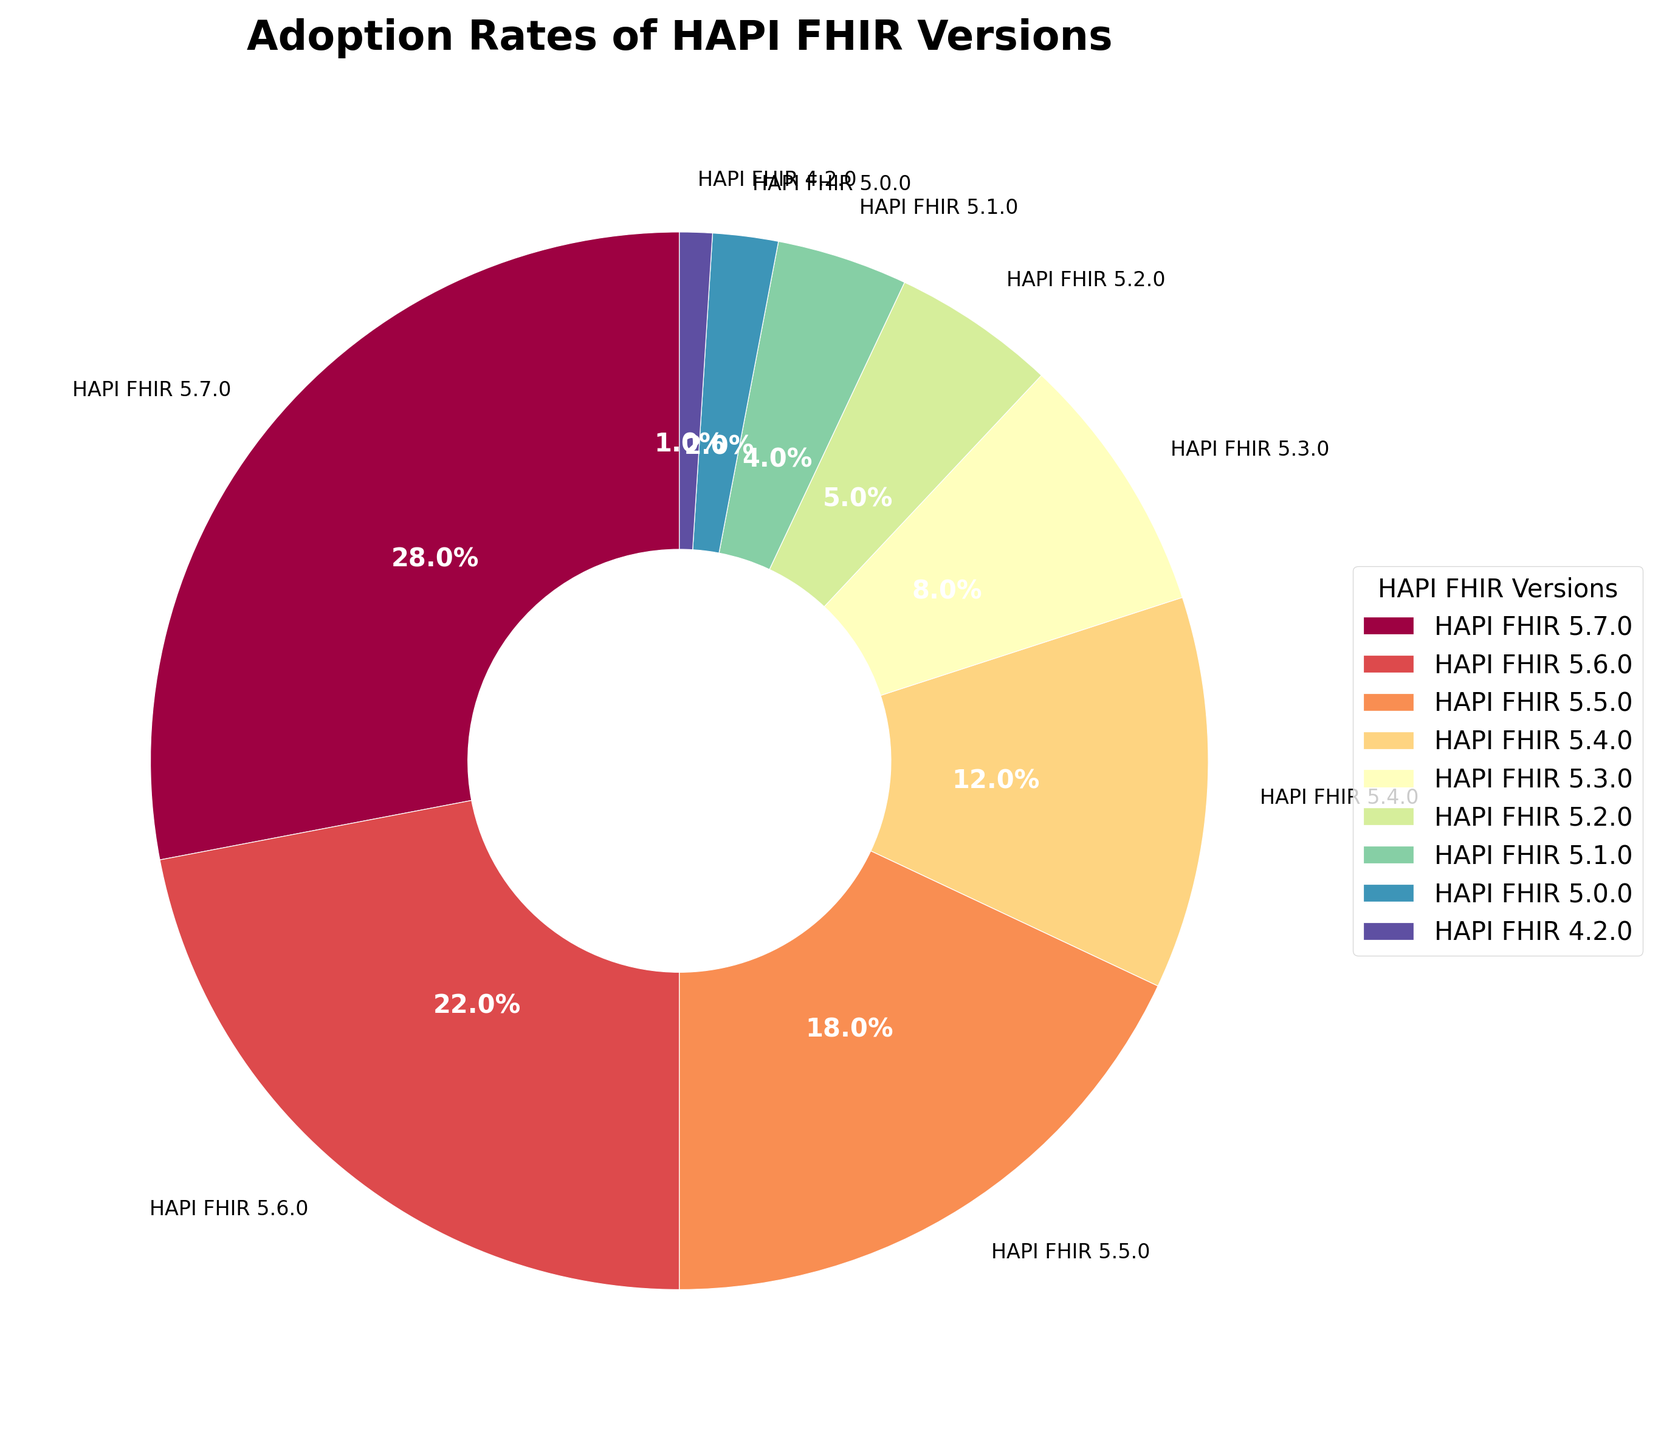What is the adoption percentage of HAPI FHIR 5.6.0? The pie chart shows each version and its corresponding adoption percentage. Locate the label for HAPI FHIR 5.6.0 and read the associated percentage value.
Answer: 22% Which HAPI FHIR version has the highest adoption rate? Identify the segment of the pie chart that is the largest and check the label associated with it. The largest segment represents the version with the highest adoption rate.
Answer: HAPI FHIR 5.7.0 What is the total adoption percentage of the versions HAPI FHIR 5.5.0 and HAPI FHIR 5.4.0 combined? Find the adoption percentages for HAPI FHIR 5.5.0 and HAPI FHIR 5.4.0 from the chart. Add these percentages together to get the total.
Answer: 30% Which version has a lower adoption percentage, HAPI FHIR 5.3.0 or HAPI FHIR 4.2.0? Compare the respective segments for HAPI FHIR 5.3.0 and HAPI FHIR 4.2.0. Check their adoption percentages directly from the pie chart.
Answer: HAPI FHIR 4.2.0 What are the adoption percentages for all versions represented by segments with a darker shade in the chart? Look at the color gradient in the pie chart and identify which segments have darker shades. Sum the adoption percentages for these versions. This assumes we are using natural shading where darker usually represents higher or significant values. Ensure specific segments are clearly distinguishable from the visual attributes described.
Answer: 63% (combining HAPI FHIR 5.7.0, HAPI FHIR 5.6.0, and HAPI FHIR 5.5.0) Which version sees a higher adoption rate: HAPI FHIR 5.1.0 or HAPI FHIR 5.0.0? Compare the adoption percentages directly on the pie chart for HAPI FHIR 5.1.0 and HAPI FHIR 5.0.0.
Answer: HAPI FHIR 5.1.0 What is the percentage difference between HAPI FHIR 5.7.0 and HAPI FHIR 5.5.0? Find the adoption percentages for both versions HAPI FHIR 5.7.0 and HAPI FHIR 5.5.0. Subtract the percentage of HAPI FHIR 5.5.0 from HAPI FHIR 5.7.0 to get the difference.
Answer: 10% What is the sum of the adoption rates for all versions that have an adoption percentage less than 10%? Identify all versions with adoption percentages less than 10%. Sum these percentages together to find the total.
Answer: 20% How many versions have an adoption rate greater than 15%? Count the number of segments in the pie chart that have adoption percentages greater than 15%.
Answer: 3 